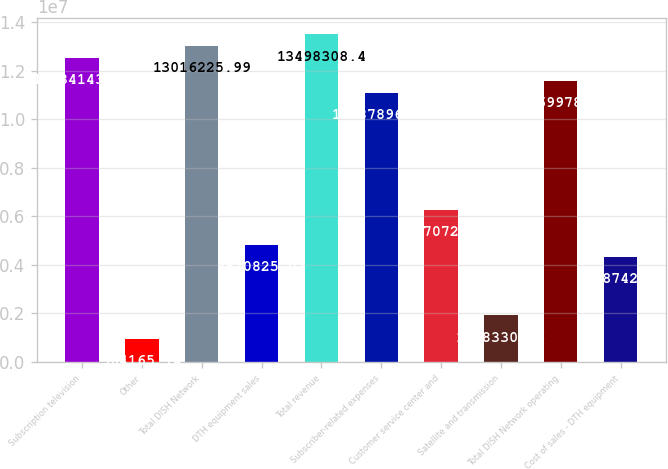Convert chart to OTSL. <chart><loc_0><loc_0><loc_500><loc_500><bar_chart><fcel>Subscription television<fcel>Other<fcel>Total DISH Network<fcel>DTH equipment sales<fcel>Total revenue<fcel>Subscriber-related expenses<fcel>Customer service center and<fcel>Satellite and transmission<fcel>Total DISH Network operating<fcel>Cost of sales - DTH equipment<nl><fcel>1.25341e+07<fcel>964166<fcel>1.30162e+07<fcel>4.82083e+06<fcel>1.34983e+07<fcel>1.10879e+07<fcel>6.26707e+06<fcel>1.92833e+06<fcel>1.157e+07<fcel>4.33874e+06<nl></chart> 